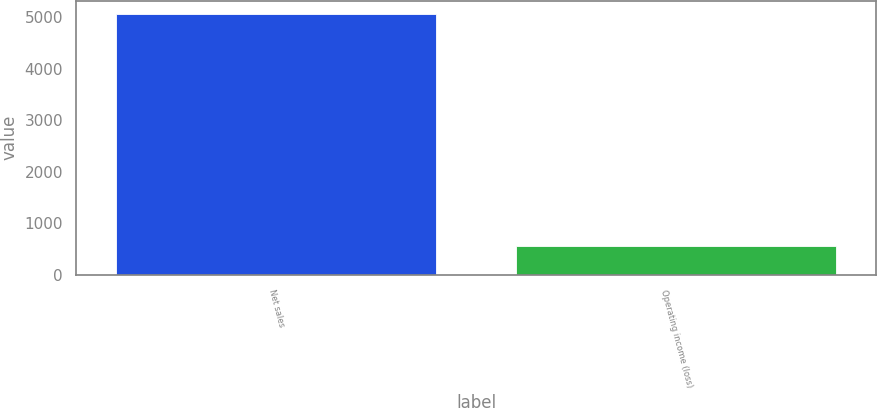<chart> <loc_0><loc_0><loc_500><loc_500><bar_chart><fcel>Net sales<fcel>Operating income (loss)<nl><fcel>5071<fcel>564<nl></chart> 